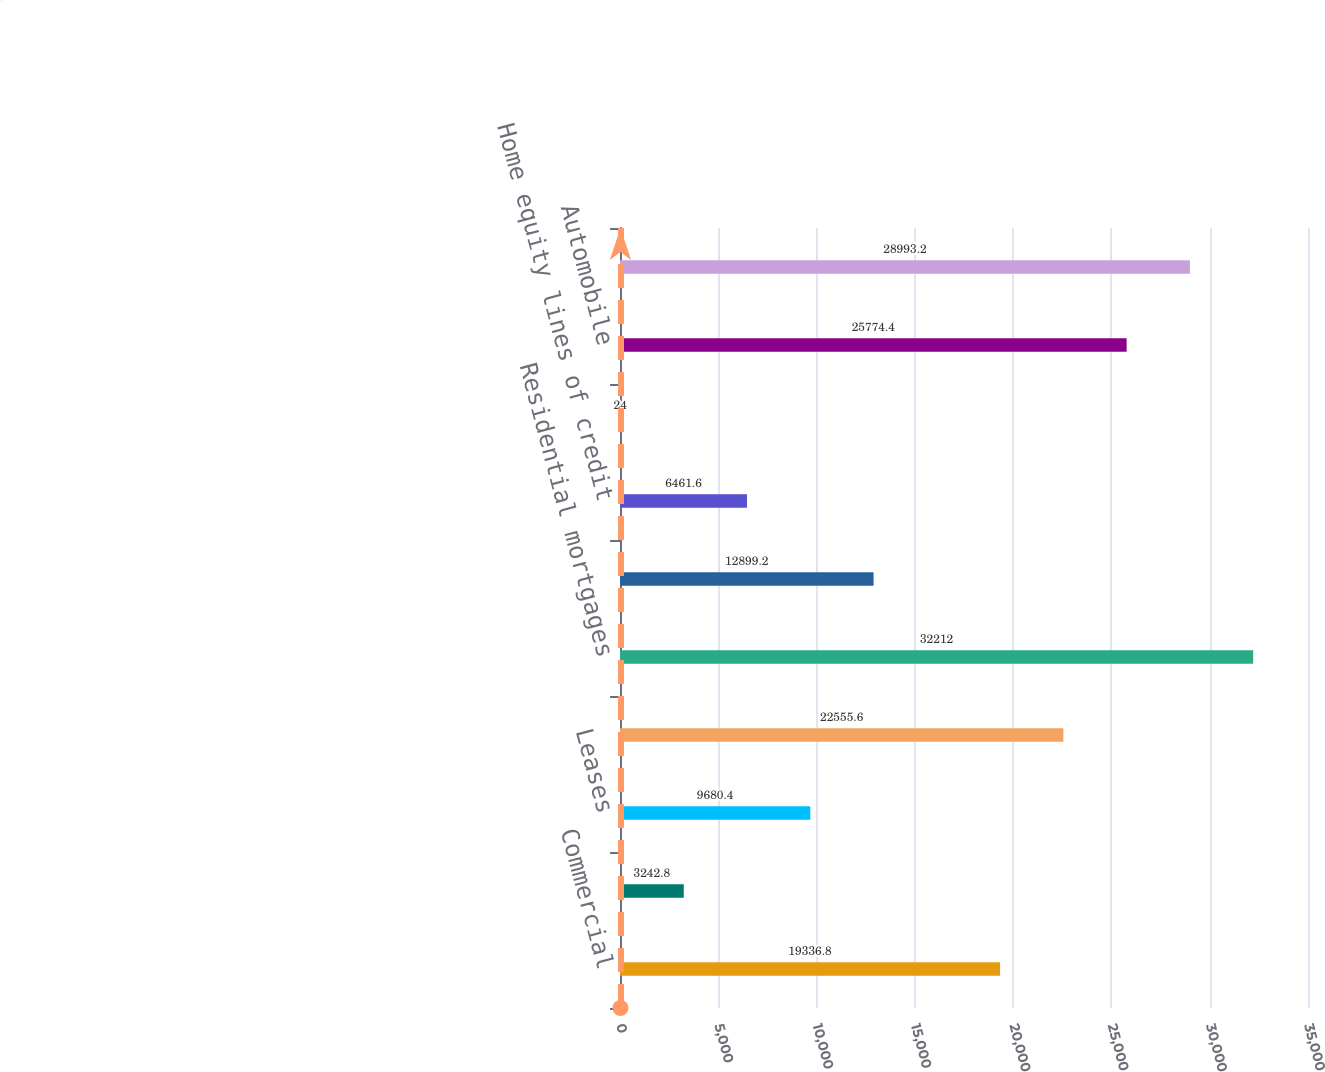<chart> <loc_0><loc_0><loc_500><loc_500><bar_chart><fcel>Commercial<fcel>Commercial real estate<fcel>Leases<fcel>Total commercial loans and<fcel>Residential mortgages<fcel>Home equity loans<fcel>Home equity lines of credit<fcel>Home equity loans serviced by<fcel>Automobile<fcel>Education<nl><fcel>19336.8<fcel>3242.8<fcel>9680.4<fcel>22555.6<fcel>32212<fcel>12899.2<fcel>6461.6<fcel>24<fcel>25774.4<fcel>28993.2<nl></chart> 